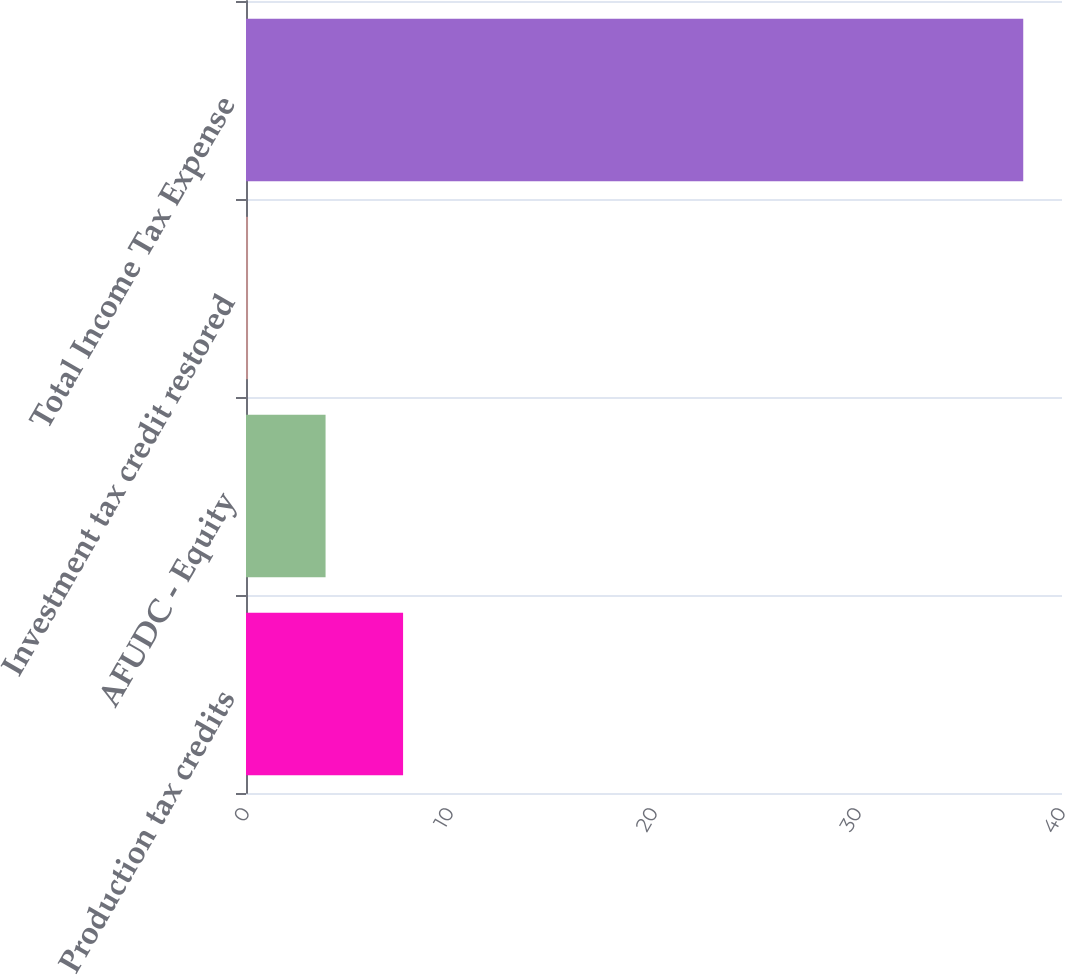<chart> <loc_0><loc_0><loc_500><loc_500><bar_chart><fcel>Production tax credits<fcel>AFUDC - Equity<fcel>Investment tax credit restored<fcel>Total Income Tax Expense<nl><fcel>7.7<fcel>3.9<fcel>0.1<fcel>38.1<nl></chart> 